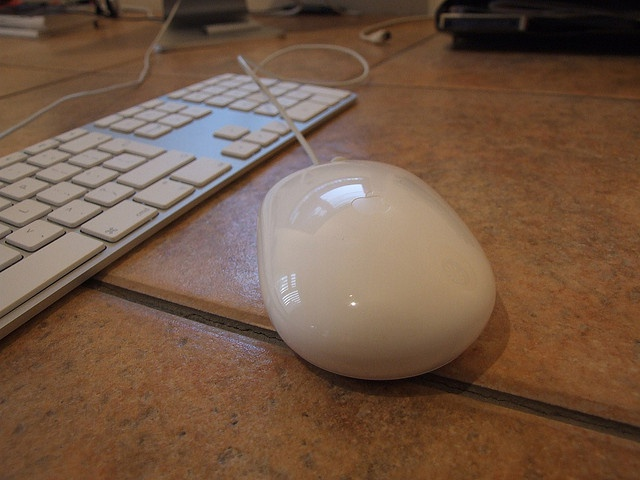Describe the objects in this image and their specific colors. I can see keyboard in black, darkgray, and gray tones and mouse in black, darkgray, tan, gray, and maroon tones in this image. 